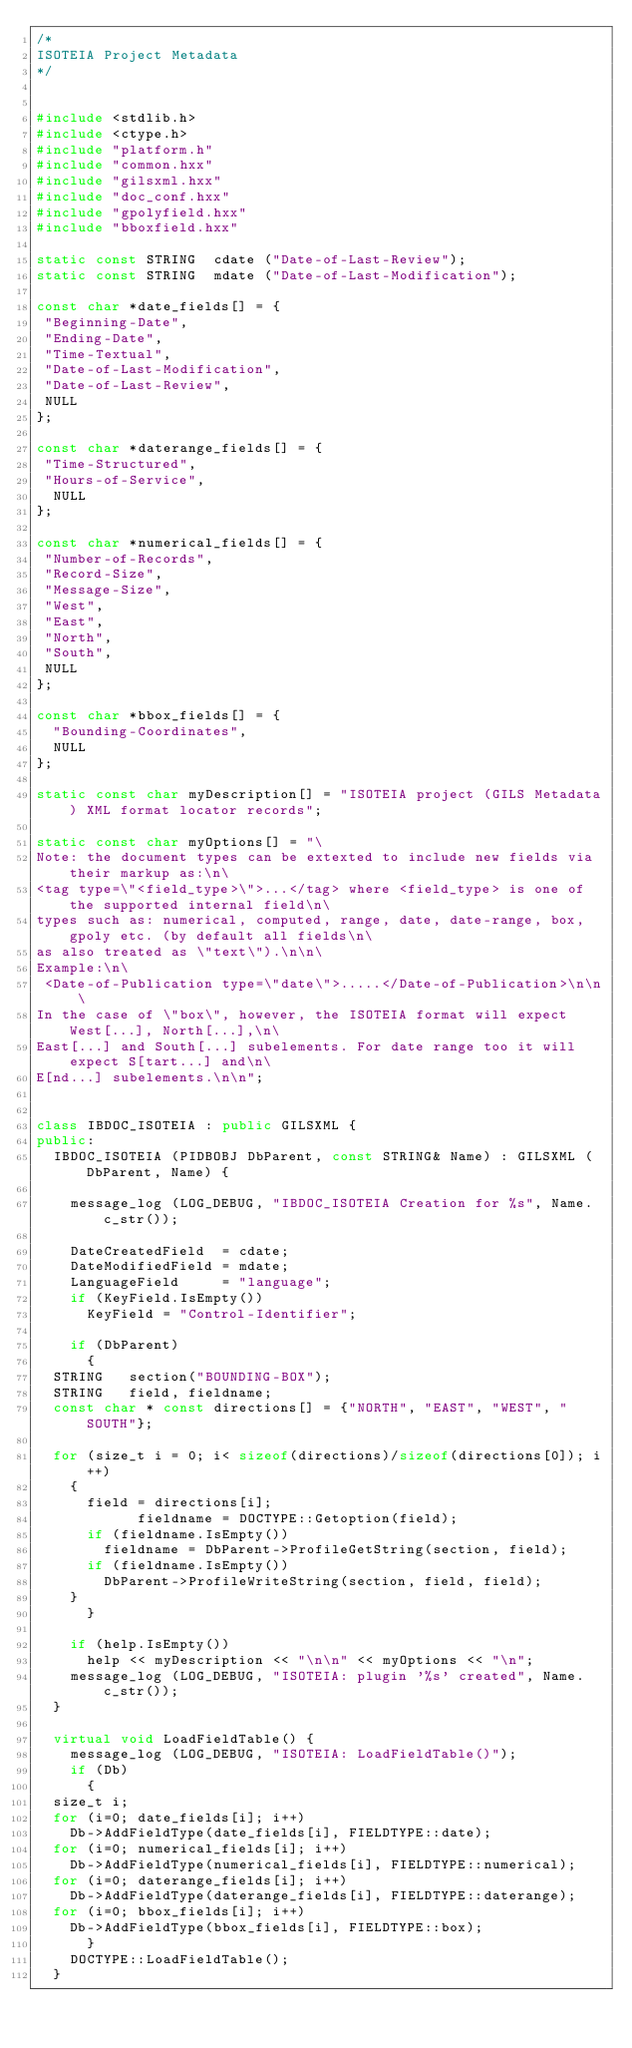<code> <loc_0><loc_0><loc_500><loc_500><_C++_>/*
ISOTEIA Project Metadata
*/


#include <stdlib.h>
#include <ctype.h>
#include "platform.h"
#include "common.hxx"
#include "gilsxml.hxx"
#include "doc_conf.hxx"
#include "gpolyfield.hxx"
#include "bboxfield.hxx"

static const STRING  cdate ("Date-of-Last-Review");
static const STRING  mdate ("Date-of-Last-Modification");

const char *date_fields[] = {
 "Beginning-Date",
 "Ending-Date",
 "Time-Textual",
 "Date-of-Last-Modification",
 "Date-of-Last-Review",
 NULL
};

const char *daterange_fields[] = {
 "Time-Structured",
 "Hours-of-Service",
  NULL
};

const char *numerical_fields[] = {
 "Number-of-Records",
 "Record-Size",
 "Message-Size",
 "West", 
 "East",
 "North",
 "South",
 NULL
};

const char *bbox_fields[] = {
  "Bounding-Coordinates",
  NULL
};

static const char myDescription[] = "ISOTEIA project (GILS Metadata) XML format locator records";

static const char myOptions[] = "\
Note: the document types can be extexted to include new fields via their markup as:\n\
<tag type=\"<field_type>\">...</tag> where <field_type> is one of the supported internal field\n\
types such as: numerical, computed, range, date, date-range, box, gpoly etc. (by default all fields\n\
as also treated as \"text\").\n\n\
Example:\n\
 <Date-of-Publication type=\"date\">.....</Date-of-Publication>\n\n\
In the case of \"box\", however, the ISOTEIA format will expect West[...], North[...],\n\
East[...] and South[...] subelements. For date range too it will expect S[tart...] and\n\
E[nd...] subelements.\n\n";


class IBDOC_ISOTEIA : public GILSXML {
public:
  IBDOC_ISOTEIA (PIDBOBJ DbParent, const STRING& Name) : GILSXML (DbParent, Name) {

    message_log (LOG_DEBUG, "IBDOC_ISOTEIA Creation for %s", Name.c_str());

    DateCreatedField  = cdate;
    DateModifiedField = mdate;
    LanguageField     = "language";
    if (KeyField.IsEmpty())
      KeyField = "Control-Identifier";

    if (DbParent)
      {
	STRING   section("BOUNDING-BOX");
	STRING   field, fieldname;
	const char * const directions[] = {"NORTH", "EAST", "WEST", "SOUTH"};

	for (size_t i = 0; i< sizeof(directions)/sizeof(directions[0]); i++)
	  {
	    field = directions[i];
            fieldname = DOCTYPE::Getoption(field);
	    if (fieldname.IsEmpty())
	      fieldname = DbParent->ProfileGetString(section, field);
	    if (fieldname.IsEmpty())
	      DbParent->ProfileWriteString(section, field, field);
	  }
      }	

    if (help.IsEmpty())
      help << myDescription << "\n\n" << myOptions << "\n";
    message_log (LOG_DEBUG, "ISOTEIA: plugin '%s' created", Name.c_str());
  }

  virtual void LoadFieldTable() {
    message_log (LOG_DEBUG, "ISOTEIA: LoadFieldTable()");
    if (Db)
      {
	size_t i;
	for (i=0; date_fields[i]; i++)
	  Db->AddFieldType(date_fields[i], FIELDTYPE::date);
	for (i=0; numerical_fields[i]; i++)
	  Db->AddFieldType(numerical_fields[i], FIELDTYPE::numerical);
	for (i=0; daterange_fields[i]; i++)
	  Db->AddFieldType(daterange_fields[i], FIELDTYPE::daterange);
	for (i=0; bbox_fields[i]; i++)
	  Db->AddFieldType(bbox_fields[i], FIELDTYPE::box);
      }
    DOCTYPE::LoadFieldTable();
  }
</code> 